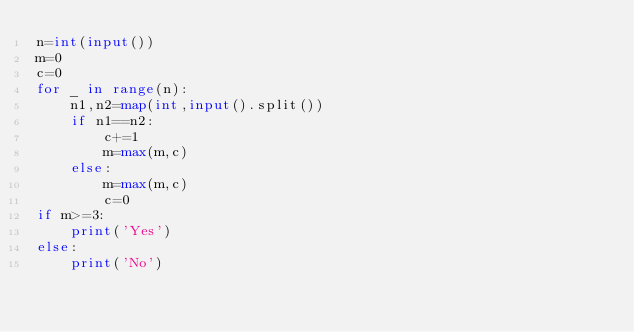Convert code to text. <code><loc_0><loc_0><loc_500><loc_500><_Python_>n=int(input())
m=0
c=0
for _ in range(n):
	n1,n2=map(int,input().split())
	if n1==n2:
		c+=1
		m=max(m,c)
	else:
		m=max(m,c)
		c=0
if m>=3:
	print('Yes')
else:
	print('No')</code> 